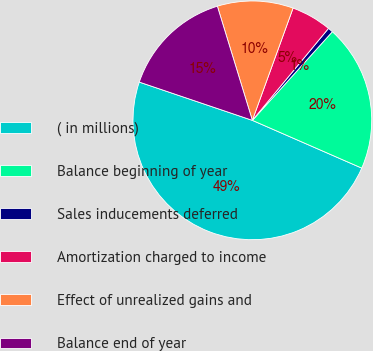Convert chart. <chart><loc_0><loc_0><loc_500><loc_500><pie_chart><fcel>( in millions)<fcel>Balance beginning of year<fcel>Sales inducements deferred<fcel>Amortization charged to income<fcel>Effect of unrealized gains and<fcel>Balance end of year<nl><fcel>48.64%<fcel>19.86%<fcel>0.68%<fcel>5.47%<fcel>10.27%<fcel>15.07%<nl></chart> 